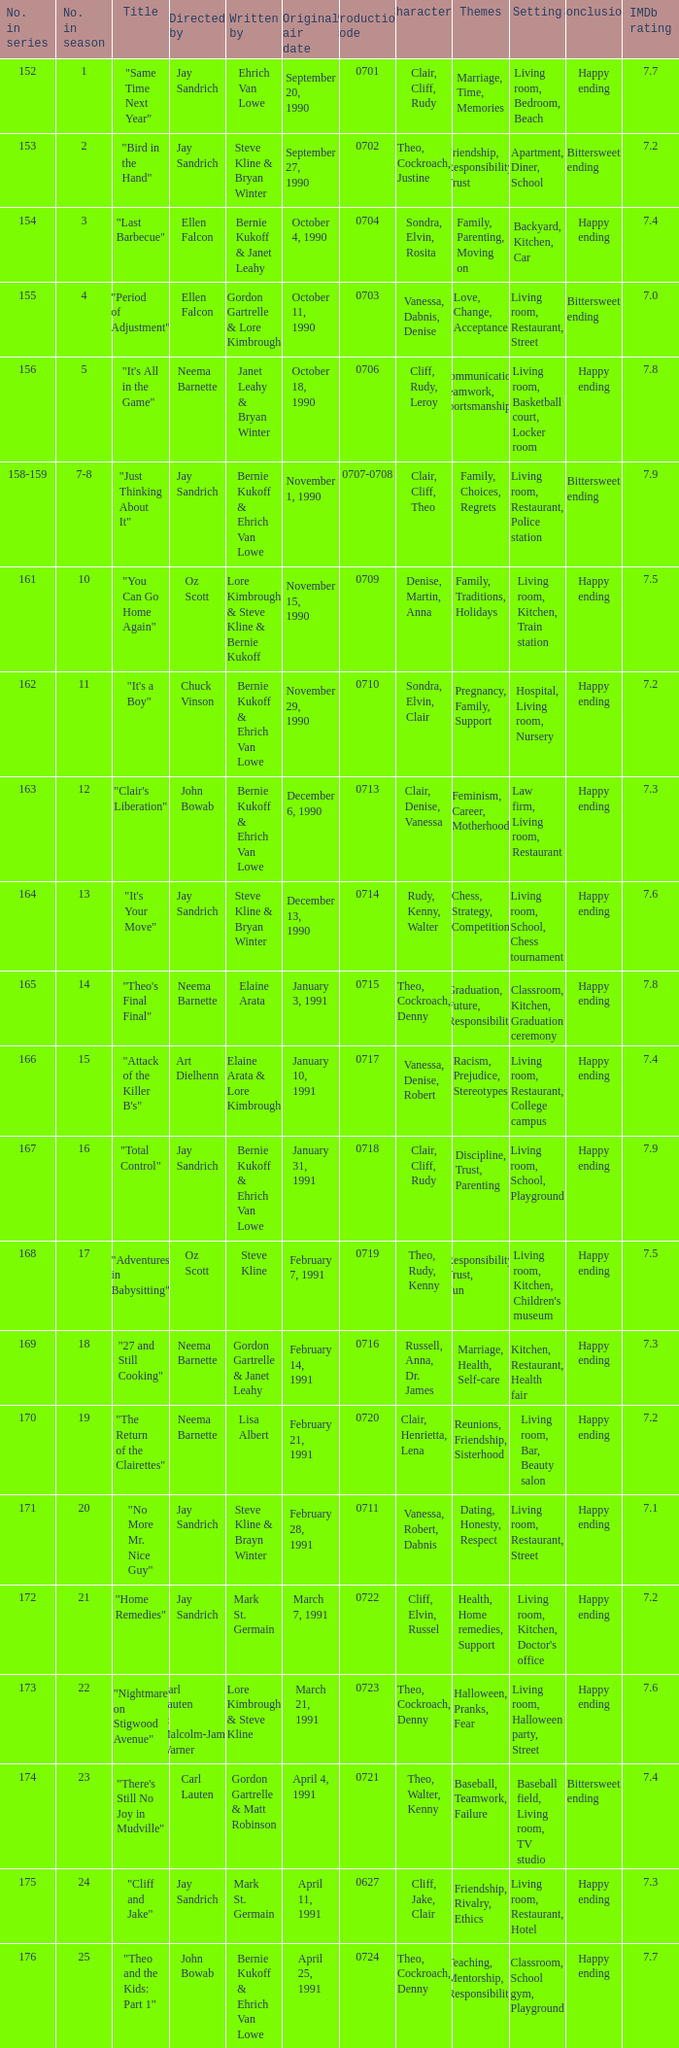Who directed the episode entitled "it's your move"? Jay Sandrich. Write the full table. {'header': ['No. in series', 'No. in season', 'Title', 'Directed by', 'Written by', 'Original air date', 'Production code', 'Characters', 'Themes', 'Setting', 'Conclusion', 'IMDb rating'], 'rows': [['152', '1', '"Same Time Next Year"', 'Jay Sandrich', 'Ehrich Van Lowe', 'September 20, 1990', '0701', 'Clair, Cliff, Rudy', 'Marriage, Time, Memories', 'Living room, Bedroom, Beach', 'Happy ending', '7.7'], ['153', '2', '"Bird in the Hand"', 'Jay Sandrich', 'Steve Kline & Bryan Winter', 'September 27, 1990', '0702', 'Theo, Cockroach, Justine', 'Friendship, Responsibility, Trust', 'Apartment, Diner, School', 'Bittersweet ending', '7.2'], ['154', '3', '"Last Barbecue"', 'Ellen Falcon', 'Bernie Kukoff & Janet Leahy', 'October 4, 1990', '0704', 'Sondra, Elvin, Rosita', 'Family, Parenting, Moving on', 'Backyard, Kitchen, Car', 'Happy ending', '7.4'], ['155', '4', '"Period of Adjustment"', 'Ellen Falcon', 'Gordon Gartrelle & Lore Kimbrough', 'October 11, 1990', '0703', 'Vanessa, Dabnis, Denise', 'Love, Change, Acceptance', 'Living room, Restaurant, Street', 'Bittersweet ending', '7.0'], ['156', '5', '"It\'s All in the Game"', 'Neema Barnette', 'Janet Leahy & Bryan Winter', 'October 18, 1990', '0706', 'Cliff, Rudy, Leroy', 'Communication, Teamwork, Sportsmanship', 'Living room, Basketball court, Locker room', 'Happy ending', '7.8'], ['158-159', '7-8', '"Just Thinking About It"', 'Jay Sandrich', 'Bernie Kukoff & Ehrich Van Lowe', 'November 1, 1990', '0707-0708', 'Clair, Cliff, Theo', 'Family, Choices, Regrets', 'Living room, Restaurant, Police station', 'Bittersweet ending', '7.9'], ['161', '10', '"You Can Go Home Again"', 'Oz Scott', 'Lore Kimbrough & Steve Kline & Bernie Kukoff', 'November 15, 1990', '0709', 'Denise, Martin, Anna', 'Family, Traditions, Holidays', 'Living room, Kitchen, Train station', 'Happy ending', '7.5'], ['162', '11', '"It\'s a Boy"', 'Chuck Vinson', 'Bernie Kukoff & Ehrich Van Lowe', 'November 29, 1990', '0710', 'Sondra, Elvin, Clair', 'Pregnancy, Family, Support', 'Hospital, Living room, Nursery', 'Happy ending', '7.2'], ['163', '12', '"Clair\'s Liberation"', 'John Bowab', 'Bernie Kukoff & Ehrich Van Lowe', 'December 6, 1990', '0713', 'Clair, Denise, Vanessa', 'Feminism, Career, Motherhood', 'Law firm, Living room, Restaurant', 'Happy ending', '7.3'], ['164', '13', '"It\'s Your Move"', 'Jay Sandrich', 'Steve Kline & Bryan Winter', 'December 13, 1990', '0714', 'Rudy, Kenny, Walter', 'Chess, Strategy, Competition', 'Living room, School, Chess tournament', 'Happy ending', '7.6'], ['165', '14', '"Theo\'s Final Final"', 'Neema Barnette', 'Elaine Arata', 'January 3, 1991', '0715', 'Theo, Cockroach, Denny', 'Graduation, Future, Responsibility', 'Classroom, Kitchen, Graduation ceremony', 'Happy ending', '7.8'], ['166', '15', '"Attack of the Killer B\'s"', 'Art Dielhenn', 'Elaine Arata & Lore Kimbrough', 'January 10, 1991', '0717', 'Vanessa, Denise, Robert', 'Racism, Prejudice, Stereotypes', 'Living room, Restaurant, College campus', 'Happy ending', '7.4'], ['167', '16', '"Total Control"', 'Jay Sandrich', 'Bernie Kukoff & Ehrich Van Lowe', 'January 31, 1991', '0718', 'Clair, Cliff, Rudy', 'Discipline, Trust, Parenting', 'Living room, School, Playground', 'Happy ending', '7.9'], ['168', '17', '"Adventures in Babysitting"', 'Oz Scott', 'Steve Kline', 'February 7, 1991', '0719', 'Theo, Rudy, Kenny', 'Responsibility, Trust, Fun', "Living room, Kitchen, Children's museum", 'Happy ending', '7.5'], ['169', '18', '"27 and Still Cooking"', 'Neema Barnette', 'Gordon Gartrelle & Janet Leahy', 'February 14, 1991', '0716', 'Russell, Anna, Dr. James', 'Marriage, Health, Self-care', 'Kitchen, Restaurant, Health fair', 'Happy ending', '7.3'], ['170', '19', '"The Return of the Clairettes"', 'Neema Barnette', 'Lisa Albert', 'February 21, 1991', '0720', 'Clair, Henrietta, Lena', 'Reunions, Friendship, Sisterhood', 'Living room, Bar, Beauty salon', 'Happy ending', '7.2'], ['171', '20', '"No More Mr. Nice Guy"', 'Jay Sandrich', 'Steve Kline & Brayn Winter', 'February 28, 1991', '0711', 'Vanessa, Robert, Dabnis', 'Dating, Honesty, Respect', 'Living room, Restaurant, Street', 'Happy ending', '7.1'], ['172', '21', '"Home Remedies"', 'Jay Sandrich', 'Mark St. Germain', 'March 7, 1991', '0722', 'Cliff, Elvin, Russel', 'Health, Home remedies, Support', "Living room, Kitchen, Doctor's office", 'Happy ending', '7.2'], ['173', '22', '"Nightmare on Stigwood Avenue"', 'Carl Lauten & Malcolm-Jamal Warner', 'Lore Kimbrough & Steve Kline', 'March 21, 1991', '0723', 'Theo, Cockroach, Denny', 'Halloween, Pranks, Fear', 'Living room, Halloween party, Street', 'Happy ending', '7.6'], ['174', '23', '"There\'s Still No Joy in Mudville"', 'Carl Lauten', 'Gordon Gartrelle & Matt Robinson', 'April 4, 1991', '0721', 'Theo, Walter, Kenny', 'Baseball, Teamwork, Failure', 'Baseball field, Living room, TV studio', 'Bittersweet ending', '7.4'], ['175', '24', '"Cliff and Jake"', 'Jay Sandrich', 'Mark St. Germain', 'April 11, 1991', '0627', 'Cliff, Jake, Clair', 'Friendship, Rivalry, Ethics', 'Living room, Restaurant, Hotel', 'Happy ending', '7.3'], ['176', '25', '"Theo and the Kids: Part 1"', 'John Bowab', 'Bernie Kukoff & Ehrich Van Lowe', 'April 25, 1991', '0724', 'Theo, Cockroach, Denny', 'Teaching, Mentorship, Responsibility', 'Classroom, School gym, Playground', 'Happy ending', '7.7']]} 